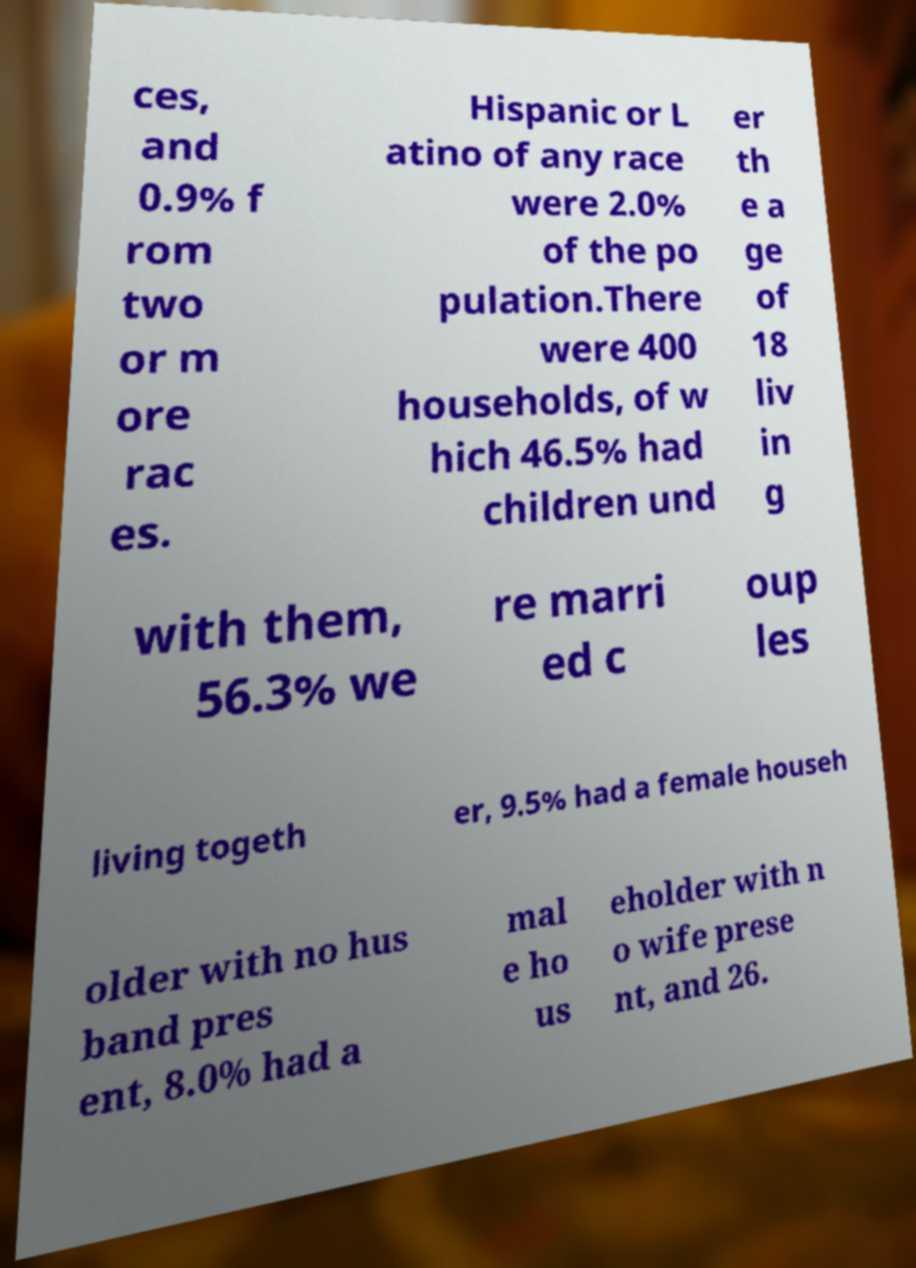There's text embedded in this image that I need extracted. Can you transcribe it verbatim? ces, and 0.9% f rom two or m ore rac es. Hispanic or L atino of any race were 2.0% of the po pulation.There were 400 households, of w hich 46.5% had children und er th e a ge of 18 liv in g with them, 56.3% we re marri ed c oup les living togeth er, 9.5% had a female househ older with no hus band pres ent, 8.0% had a mal e ho us eholder with n o wife prese nt, and 26. 